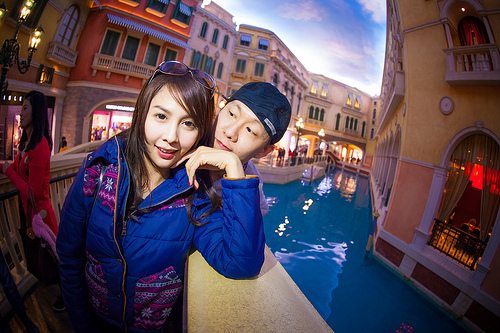<image>
Is there a woman behind the man? No. The woman is not behind the man. From this viewpoint, the woman appears to be positioned elsewhere in the scene. Where is the water in relation to the man? Is it in front of the man? No. The water is not in front of the man. The spatial positioning shows a different relationship between these objects. 